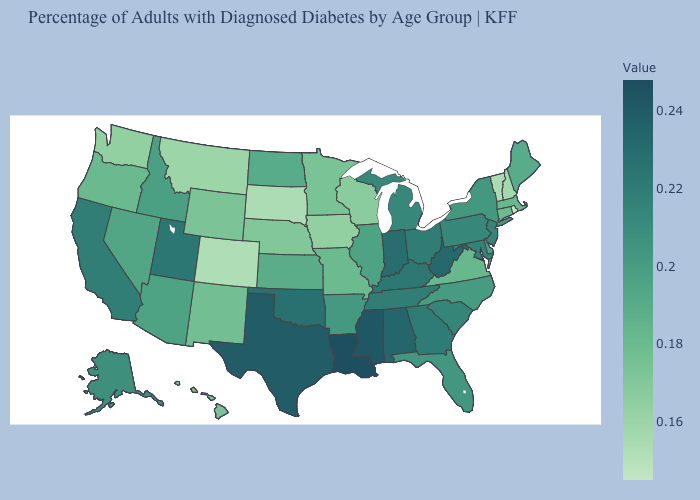Does Nebraska have a higher value than Alaska?
Concise answer only. No. Among the states that border Massachusetts , does New York have the highest value?
Write a very short answer. Yes. Which states have the lowest value in the South?
Keep it brief. Virginia. Which states have the highest value in the USA?
Concise answer only. Louisiana. Does Tennessee have the highest value in the USA?
Keep it brief. No. Among the states that border California , does Oregon have the highest value?
Be succinct. No. 